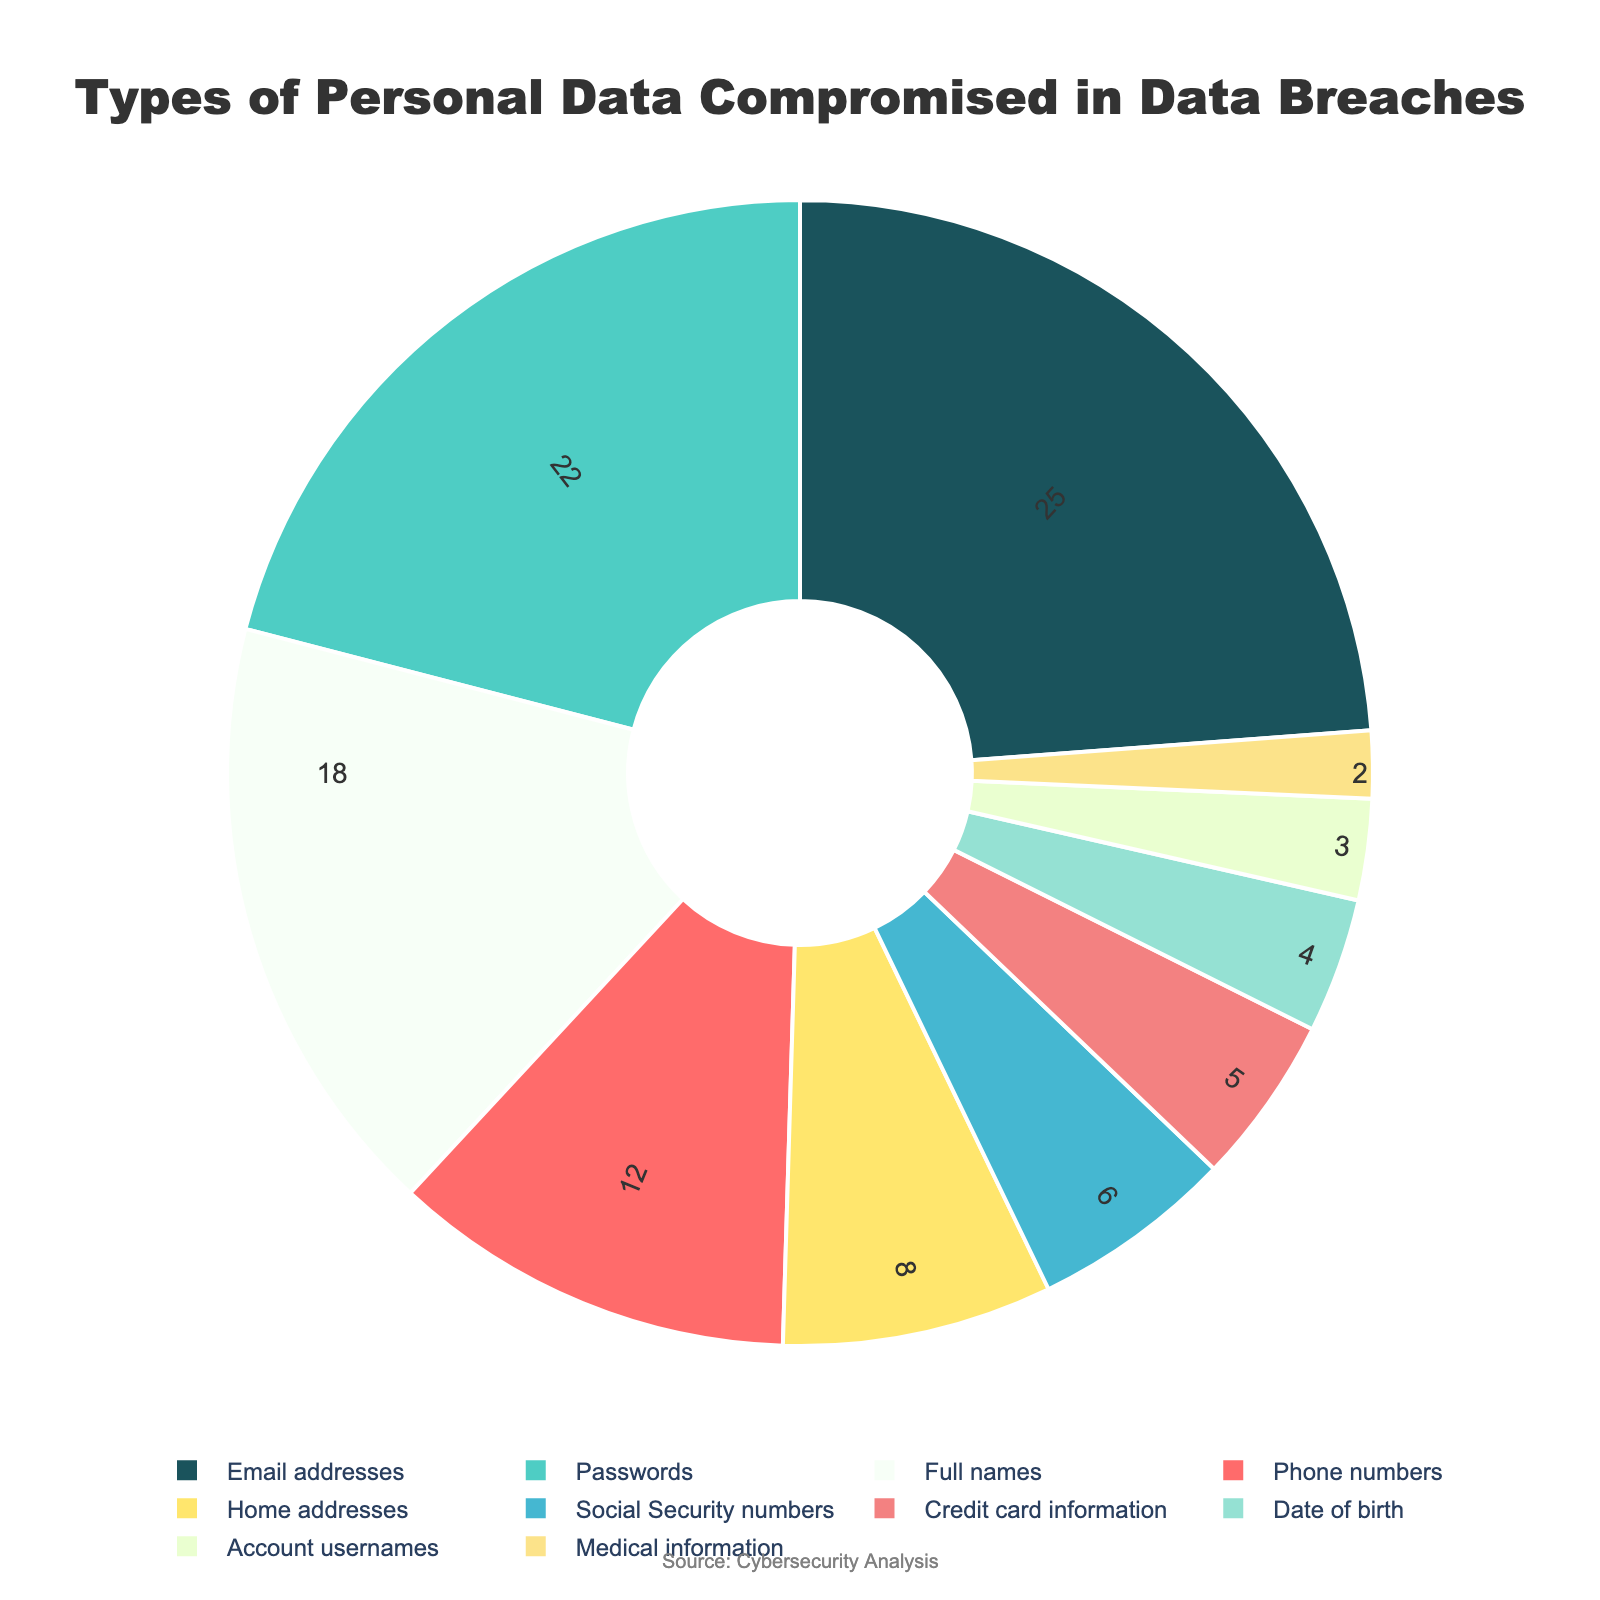Which type of personal data is the most commonly compromised in data breaches? The data shows that the largest segment is "Email addresses" with a 25% share, making it the most commonly compromised type.
Answer: Email addresses Which type of personal data is compromised the least? The smallest segment is "Medical information" with a 2% share.
Answer: Medical information What percentage of compromised data is composed of Email addresses and Passwords combined? Email addresses make up 25%, and Passwords make up 22%. Combined, that's 25% + 22% = 47%.
Answer: 47% Are Full names more commonly compromised than Home addresses? By how much? Full names constitute 18% of compromises, while Home addresses account for 8%. The difference is 18% - 8% = 10%.
Answer: Yes, by 10% How many data types have percentages greater than 10%? Review the chart: Email addresses (25%), Passwords (22%), Full names (18%), and Phone numbers (12%) all have percentages greater than 10%. That makes 4 types.
Answer: 4 Which data type is less commonly compromised: Account usernames or Date of birth? Account usernames make up 3%, while Date of birth is 4%. Thus, Account usernames are less commonly compromised.
Answer: Account usernames How does the percentage of compromised Social Security numbers compare to that of Credit card information? Social Security numbers account for 6%, while Credit card information accounts for 5%. Social Security numbers have a 1% higher compromise rate.
Answer: Social Security numbers have a 1% higher rate What's the total percentage of compromises involving financial information (Credit card information and Social Security numbers)? Credit card information comprises 5% and Social Security numbers 6%. Total is 5% + 6% = 11%.
Answer: 11% Is the percentage of Phone numbers being compromised greater than or equal to that of Full names? Phone numbers represent 12%, while Full names are at 18%. Thus, Phone numbers are not greater than or equal to Full names.
Answer: No What is the combined percentage of compromises for Account usernames, Medical information, and Date of birth? Account usernames (3%), Medical information (2%), and Date of birth (4%) sum up to 3% + 2% + 4% = 9%.
Answer: 9% 